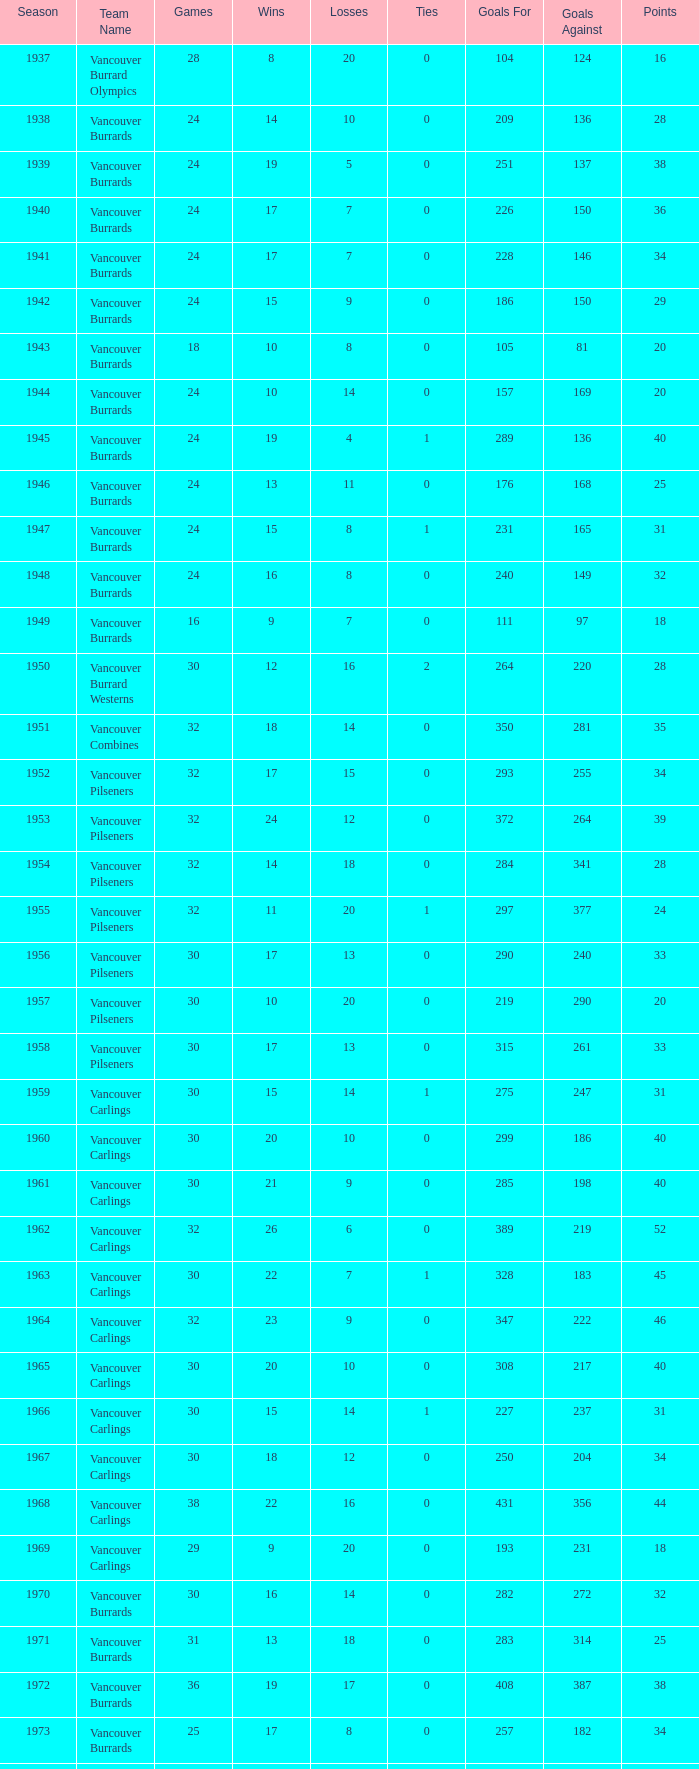What's the total losses for the vancouver burrards in the 1947 season with fewer than 24 games? 0.0. 